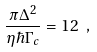Convert formula to latex. <formula><loc_0><loc_0><loc_500><loc_500>\frac { \pi \Delta ^ { 2 } } { \eta \hbar { \Gamma } _ { c } } = 1 2 \ ,</formula> 